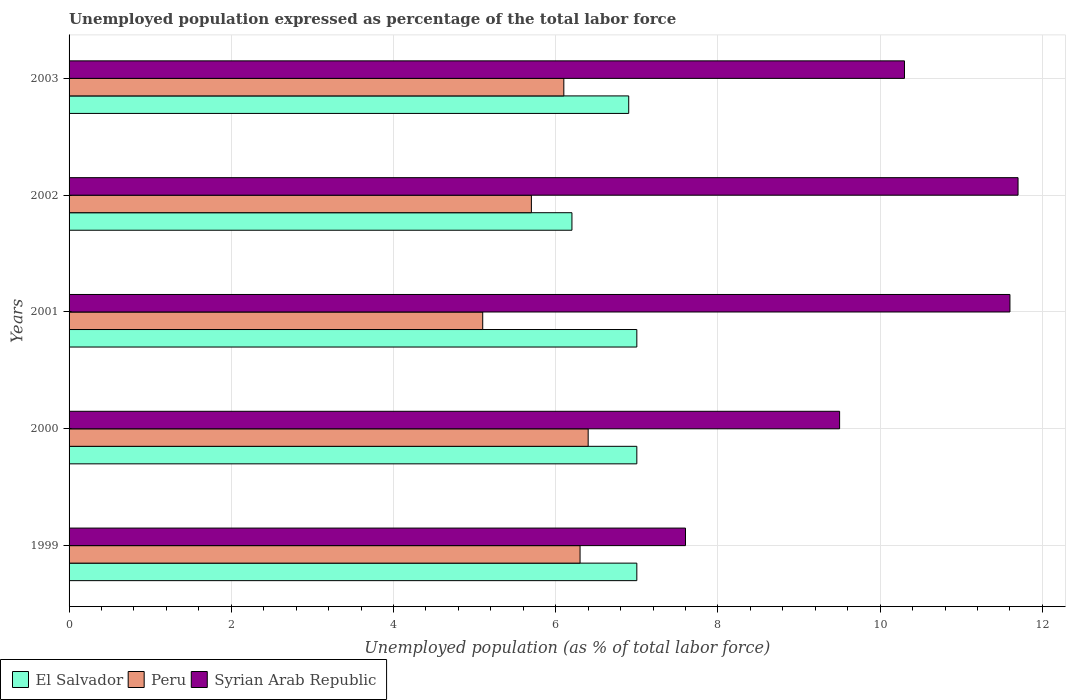Are the number of bars per tick equal to the number of legend labels?
Your response must be concise. Yes. Are the number of bars on each tick of the Y-axis equal?
Your response must be concise. Yes. How many bars are there on the 3rd tick from the bottom?
Your response must be concise. 3. What is the label of the 1st group of bars from the top?
Keep it short and to the point. 2003. In how many cases, is the number of bars for a given year not equal to the number of legend labels?
Make the answer very short. 0. What is the unemployment in in El Salvador in 2002?
Provide a succinct answer. 6.2. Across all years, what is the maximum unemployment in in Peru?
Your answer should be compact. 6.4. Across all years, what is the minimum unemployment in in El Salvador?
Offer a terse response. 6.2. In which year was the unemployment in in Syrian Arab Republic maximum?
Provide a short and direct response. 2002. What is the total unemployment in in Syrian Arab Republic in the graph?
Ensure brevity in your answer.  50.7. What is the difference between the unemployment in in El Salvador in 1999 and that in 2000?
Offer a terse response. 0. What is the average unemployment in in Syrian Arab Republic per year?
Keep it short and to the point. 10.14. In the year 1999, what is the difference between the unemployment in in Peru and unemployment in in Syrian Arab Republic?
Offer a very short reply. -1.3. In how many years, is the unemployment in in El Salvador greater than 0.4 %?
Provide a succinct answer. 5. What is the ratio of the unemployment in in Peru in 1999 to that in 2000?
Ensure brevity in your answer.  0.98. Is the unemployment in in El Salvador in 2002 less than that in 2003?
Offer a terse response. Yes. What is the difference between the highest and the second highest unemployment in in Peru?
Provide a succinct answer. 0.1. What is the difference between the highest and the lowest unemployment in in Syrian Arab Republic?
Your answer should be compact. 4.1. What does the 3rd bar from the top in 2003 represents?
Your answer should be very brief. El Salvador. What does the 2nd bar from the bottom in 2003 represents?
Ensure brevity in your answer.  Peru. Is it the case that in every year, the sum of the unemployment in in Peru and unemployment in in Syrian Arab Republic is greater than the unemployment in in El Salvador?
Offer a terse response. Yes. What is the difference between two consecutive major ticks on the X-axis?
Your answer should be compact. 2. Are the values on the major ticks of X-axis written in scientific E-notation?
Ensure brevity in your answer.  No. Where does the legend appear in the graph?
Provide a short and direct response. Bottom left. How many legend labels are there?
Your answer should be very brief. 3. What is the title of the graph?
Your response must be concise. Unemployed population expressed as percentage of the total labor force. What is the label or title of the X-axis?
Provide a succinct answer. Unemployed population (as % of total labor force). What is the label or title of the Y-axis?
Give a very brief answer. Years. What is the Unemployed population (as % of total labor force) of Peru in 1999?
Make the answer very short. 6.3. What is the Unemployed population (as % of total labor force) of Syrian Arab Republic in 1999?
Your answer should be compact. 7.6. What is the Unemployed population (as % of total labor force) in El Salvador in 2000?
Provide a succinct answer. 7. What is the Unemployed population (as % of total labor force) in Peru in 2000?
Your response must be concise. 6.4. What is the Unemployed population (as % of total labor force) in Syrian Arab Republic in 2000?
Ensure brevity in your answer.  9.5. What is the Unemployed population (as % of total labor force) in Peru in 2001?
Your response must be concise. 5.1. What is the Unemployed population (as % of total labor force) in Syrian Arab Republic in 2001?
Make the answer very short. 11.6. What is the Unemployed population (as % of total labor force) in El Salvador in 2002?
Ensure brevity in your answer.  6.2. What is the Unemployed population (as % of total labor force) of Peru in 2002?
Give a very brief answer. 5.7. What is the Unemployed population (as % of total labor force) of Syrian Arab Republic in 2002?
Give a very brief answer. 11.7. What is the Unemployed population (as % of total labor force) of El Salvador in 2003?
Your response must be concise. 6.9. What is the Unemployed population (as % of total labor force) in Peru in 2003?
Offer a very short reply. 6.1. What is the Unemployed population (as % of total labor force) of Syrian Arab Republic in 2003?
Your response must be concise. 10.3. Across all years, what is the maximum Unemployed population (as % of total labor force) of Peru?
Provide a short and direct response. 6.4. Across all years, what is the maximum Unemployed population (as % of total labor force) in Syrian Arab Republic?
Give a very brief answer. 11.7. Across all years, what is the minimum Unemployed population (as % of total labor force) in El Salvador?
Provide a short and direct response. 6.2. Across all years, what is the minimum Unemployed population (as % of total labor force) in Peru?
Ensure brevity in your answer.  5.1. Across all years, what is the minimum Unemployed population (as % of total labor force) in Syrian Arab Republic?
Your response must be concise. 7.6. What is the total Unemployed population (as % of total labor force) of El Salvador in the graph?
Your response must be concise. 34.1. What is the total Unemployed population (as % of total labor force) in Peru in the graph?
Provide a succinct answer. 29.6. What is the total Unemployed population (as % of total labor force) of Syrian Arab Republic in the graph?
Ensure brevity in your answer.  50.7. What is the difference between the Unemployed population (as % of total labor force) in El Salvador in 1999 and that in 2000?
Give a very brief answer. 0. What is the difference between the Unemployed population (as % of total labor force) of Peru in 1999 and that in 2000?
Make the answer very short. -0.1. What is the difference between the Unemployed population (as % of total labor force) of El Salvador in 1999 and that in 2001?
Provide a short and direct response. 0. What is the difference between the Unemployed population (as % of total labor force) of Peru in 1999 and that in 2001?
Offer a very short reply. 1.2. What is the difference between the Unemployed population (as % of total labor force) in Syrian Arab Republic in 1999 and that in 2001?
Offer a very short reply. -4. What is the difference between the Unemployed population (as % of total labor force) in Peru in 1999 and that in 2002?
Give a very brief answer. 0.6. What is the difference between the Unemployed population (as % of total labor force) in Syrian Arab Republic in 1999 and that in 2002?
Your answer should be compact. -4.1. What is the difference between the Unemployed population (as % of total labor force) in El Salvador in 1999 and that in 2003?
Give a very brief answer. 0.1. What is the difference between the Unemployed population (as % of total labor force) in Syrian Arab Republic in 1999 and that in 2003?
Give a very brief answer. -2.7. What is the difference between the Unemployed population (as % of total labor force) in El Salvador in 2000 and that in 2001?
Keep it short and to the point. 0. What is the difference between the Unemployed population (as % of total labor force) of Peru in 2000 and that in 2002?
Ensure brevity in your answer.  0.7. What is the difference between the Unemployed population (as % of total labor force) of El Salvador in 2000 and that in 2003?
Ensure brevity in your answer.  0.1. What is the difference between the Unemployed population (as % of total labor force) of Peru in 2000 and that in 2003?
Provide a succinct answer. 0.3. What is the difference between the Unemployed population (as % of total labor force) of Peru in 2001 and that in 2002?
Your answer should be compact. -0.6. What is the difference between the Unemployed population (as % of total labor force) in El Salvador in 2001 and that in 2003?
Provide a short and direct response. 0.1. What is the difference between the Unemployed population (as % of total labor force) of Peru in 2001 and that in 2003?
Your answer should be very brief. -1. What is the difference between the Unemployed population (as % of total labor force) of Peru in 2002 and that in 2003?
Your response must be concise. -0.4. What is the difference between the Unemployed population (as % of total labor force) in El Salvador in 1999 and the Unemployed population (as % of total labor force) in Peru in 2000?
Provide a short and direct response. 0.6. What is the difference between the Unemployed population (as % of total labor force) in El Salvador in 1999 and the Unemployed population (as % of total labor force) in Syrian Arab Republic in 2000?
Offer a terse response. -2.5. What is the difference between the Unemployed population (as % of total labor force) in Peru in 1999 and the Unemployed population (as % of total labor force) in Syrian Arab Republic in 2000?
Keep it short and to the point. -3.2. What is the difference between the Unemployed population (as % of total labor force) in El Salvador in 1999 and the Unemployed population (as % of total labor force) in Syrian Arab Republic in 2001?
Make the answer very short. -4.6. What is the difference between the Unemployed population (as % of total labor force) of Peru in 1999 and the Unemployed population (as % of total labor force) of Syrian Arab Republic in 2001?
Your answer should be very brief. -5.3. What is the difference between the Unemployed population (as % of total labor force) in El Salvador in 1999 and the Unemployed population (as % of total labor force) in Syrian Arab Republic in 2002?
Provide a succinct answer. -4.7. What is the difference between the Unemployed population (as % of total labor force) of Peru in 1999 and the Unemployed population (as % of total labor force) of Syrian Arab Republic in 2002?
Keep it short and to the point. -5.4. What is the difference between the Unemployed population (as % of total labor force) in El Salvador in 1999 and the Unemployed population (as % of total labor force) in Peru in 2003?
Ensure brevity in your answer.  0.9. What is the difference between the Unemployed population (as % of total labor force) in Peru in 1999 and the Unemployed population (as % of total labor force) in Syrian Arab Republic in 2003?
Ensure brevity in your answer.  -4. What is the difference between the Unemployed population (as % of total labor force) in Peru in 2000 and the Unemployed population (as % of total labor force) in Syrian Arab Republic in 2001?
Keep it short and to the point. -5.2. What is the difference between the Unemployed population (as % of total labor force) in El Salvador in 2000 and the Unemployed population (as % of total labor force) in Syrian Arab Republic in 2002?
Provide a short and direct response. -4.7. What is the difference between the Unemployed population (as % of total labor force) of Peru in 2000 and the Unemployed population (as % of total labor force) of Syrian Arab Republic in 2002?
Your response must be concise. -5.3. What is the difference between the Unemployed population (as % of total labor force) of El Salvador in 2000 and the Unemployed population (as % of total labor force) of Peru in 2003?
Keep it short and to the point. 0.9. What is the difference between the Unemployed population (as % of total labor force) of Peru in 2000 and the Unemployed population (as % of total labor force) of Syrian Arab Republic in 2003?
Make the answer very short. -3.9. What is the difference between the Unemployed population (as % of total labor force) of El Salvador in 2001 and the Unemployed population (as % of total labor force) of Peru in 2002?
Make the answer very short. 1.3. What is the difference between the Unemployed population (as % of total labor force) of El Salvador in 2001 and the Unemployed population (as % of total labor force) of Peru in 2003?
Make the answer very short. 0.9. What is the difference between the Unemployed population (as % of total labor force) in El Salvador in 2002 and the Unemployed population (as % of total labor force) in Peru in 2003?
Your answer should be very brief. 0.1. What is the difference between the Unemployed population (as % of total labor force) of Peru in 2002 and the Unemployed population (as % of total labor force) of Syrian Arab Republic in 2003?
Give a very brief answer. -4.6. What is the average Unemployed population (as % of total labor force) of El Salvador per year?
Make the answer very short. 6.82. What is the average Unemployed population (as % of total labor force) of Peru per year?
Offer a very short reply. 5.92. What is the average Unemployed population (as % of total labor force) in Syrian Arab Republic per year?
Ensure brevity in your answer.  10.14. In the year 1999, what is the difference between the Unemployed population (as % of total labor force) of El Salvador and Unemployed population (as % of total labor force) of Peru?
Keep it short and to the point. 0.7. In the year 1999, what is the difference between the Unemployed population (as % of total labor force) in El Salvador and Unemployed population (as % of total labor force) in Syrian Arab Republic?
Give a very brief answer. -0.6. In the year 2000, what is the difference between the Unemployed population (as % of total labor force) of El Salvador and Unemployed population (as % of total labor force) of Peru?
Your answer should be compact. 0.6. In the year 2000, what is the difference between the Unemployed population (as % of total labor force) of El Salvador and Unemployed population (as % of total labor force) of Syrian Arab Republic?
Provide a short and direct response. -2.5. In the year 2000, what is the difference between the Unemployed population (as % of total labor force) in Peru and Unemployed population (as % of total labor force) in Syrian Arab Republic?
Your answer should be compact. -3.1. In the year 2001, what is the difference between the Unemployed population (as % of total labor force) in El Salvador and Unemployed population (as % of total labor force) in Peru?
Keep it short and to the point. 1.9. In the year 2001, what is the difference between the Unemployed population (as % of total labor force) of El Salvador and Unemployed population (as % of total labor force) of Syrian Arab Republic?
Your answer should be compact. -4.6. In the year 2002, what is the difference between the Unemployed population (as % of total labor force) of El Salvador and Unemployed population (as % of total labor force) of Peru?
Your answer should be compact. 0.5. In the year 2002, what is the difference between the Unemployed population (as % of total labor force) of Peru and Unemployed population (as % of total labor force) of Syrian Arab Republic?
Make the answer very short. -6. In the year 2003, what is the difference between the Unemployed population (as % of total labor force) in El Salvador and Unemployed population (as % of total labor force) in Peru?
Offer a very short reply. 0.8. In the year 2003, what is the difference between the Unemployed population (as % of total labor force) of El Salvador and Unemployed population (as % of total labor force) of Syrian Arab Republic?
Make the answer very short. -3.4. What is the ratio of the Unemployed population (as % of total labor force) in El Salvador in 1999 to that in 2000?
Offer a very short reply. 1. What is the ratio of the Unemployed population (as % of total labor force) of Peru in 1999 to that in 2000?
Ensure brevity in your answer.  0.98. What is the ratio of the Unemployed population (as % of total labor force) of Syrian Arab Republic in 1999 to that in 2000?
Make the answer very short. 0.8. What is the ratio of the Unemployed population (as % of total labor force) in Peru in 1999 to that in 2001?
Your response must be concise. 1.24. What is the ratio of the Unemployed population (as % of total labor force) of Syrian Arab Republic in 1999 to that in 2001?
Provide a short and direct response. 0.66. What is the ratio of the Unemployed population (as % of total labor force) in El Salvador in 1999 to that in 2002?
Offer a very short reply. 1.13. What is the ratio of the Unemployed population (as % of total labor force) of Peru in 1999 to that in 2002?
Your response must be concise. 1.11. What is the ratio of the Unemployed population (as % of total labor force) of Syrian Arab Republic in 1999 to that in 2002?
Offer a terse response. 0.65. What is the ratio of the Unemployed population (as % of total labor force) in El Salvador in 1999 to that in 2003?
Offer a very short reply. 1.01. What is the ratio of the Unemployed population (as % of total labor force) of Peru in 1999 to that in 2003?
Your response must be concise. 1.03. What is the ratio of the Unemployed population (as % of total labor force) of Syrian Arab Republic in 1999 to that in 2003?
Your answer should be compact. 0.74. What is the ratio of the Unemployed population (as % of total labor force) of Peru in 2000 to that in 2001?
Keep it short and to the point. 1.25. What is the ratio of the Unemployed population (as % of total labor force) in Syrian Arab Republic in 2000 to that in 2001?
Offer a very short reply. 0.82. What is the ratio of the Unemployed population (as % of total labor force) of El Salvador in 2000 to that in 2002?
Give a very brief answer. 1.13. What is the ratio of the Unemployed population (as % of total labor force) of Peru in 2000 to that in 2002?
Your answer should be compact. 1.12. What is the ratio of the Unemployed population (as % of total labor force) of Syrian Arab Republic in 2000 to that in 2002?
Your response must be concise. 0.81. What is the ratio of the Unemployed population (as % of total labor force) in El Salvador in 2000 to that in 2003?
Offer a very short reply. 1.01. What is the ratio of the Unemployed population (as % of total labor force) of Peru in 2000 to that in 2003?
Keep it short and to the point. 1.05. What is the ratio of the Unemployed population (as % of total labor force) of Syrian Arab Republic in 2000 to that in 2003?
Offer a very short reply. 0.92. What is the ratio of the Unemployed population (as % of total labor force) in El Salvador in 2001 to that in 2002?
Provide a succinct answer. 1.13. What is the ratio of the Unemployed population (as % of total labor force) of Peru in 2001 to that in 2002?
Your answer should be compact. 0.89. What is the ratio of the Unemployed population (as % of total labor force) in El Salvador in 2001 to that in 2003?
Your answer should be very brief. 1.01. What is the ratio of the Unemployed population (as % of total labor force) of Peru in 2001 to that in 2003?
Give a very brief answer. 0.84. What is the ratio of the Unemployed population (as % of total labor force) of Syrian Arab Republic in 2001 to that in 2003?
Give a very brief answer. 1.13. What is the ratio of the Unemployed population (as % of total labor force) of El Salvador in 2002 to that in 2003?
Give a very brief answer. 0.9. What is the ratio of the Unemployed population (as % of total labor force) in Peru in 2002 to that in 2003?
Provide a short and direct response. 0.93. What is the ratio of the Unemployed population (as % of total labor force) of Syrian Arab Republic in 2002 to that in 2003?
Ensure brevity in your answer.  1.14. What is the difference between the highest and the second highest Unemployed population (as % of total labor force) in El Salvador?
Provide a succinct answer. 0. What is the difference between the highest and the second highest Unemployed population (as % of total labor force) of Syrian Arab Republic?
Provide a short and direct response. 0.1. What is the difference between the highest and the lowest Unemployed population (as % of total labor force) in El Salvador?
Offer a very short reply. 0.8. What is the difference between the highest and the lowest Unemployed population (as % of total labor force) in Peru?
Keep it short and to the point. 1.3. What is the difference between the highest and the lowest Unemployed population (as % of total labor force) in Syrian Arab Republic?
Ensure brevity in your answer.  4.1. 